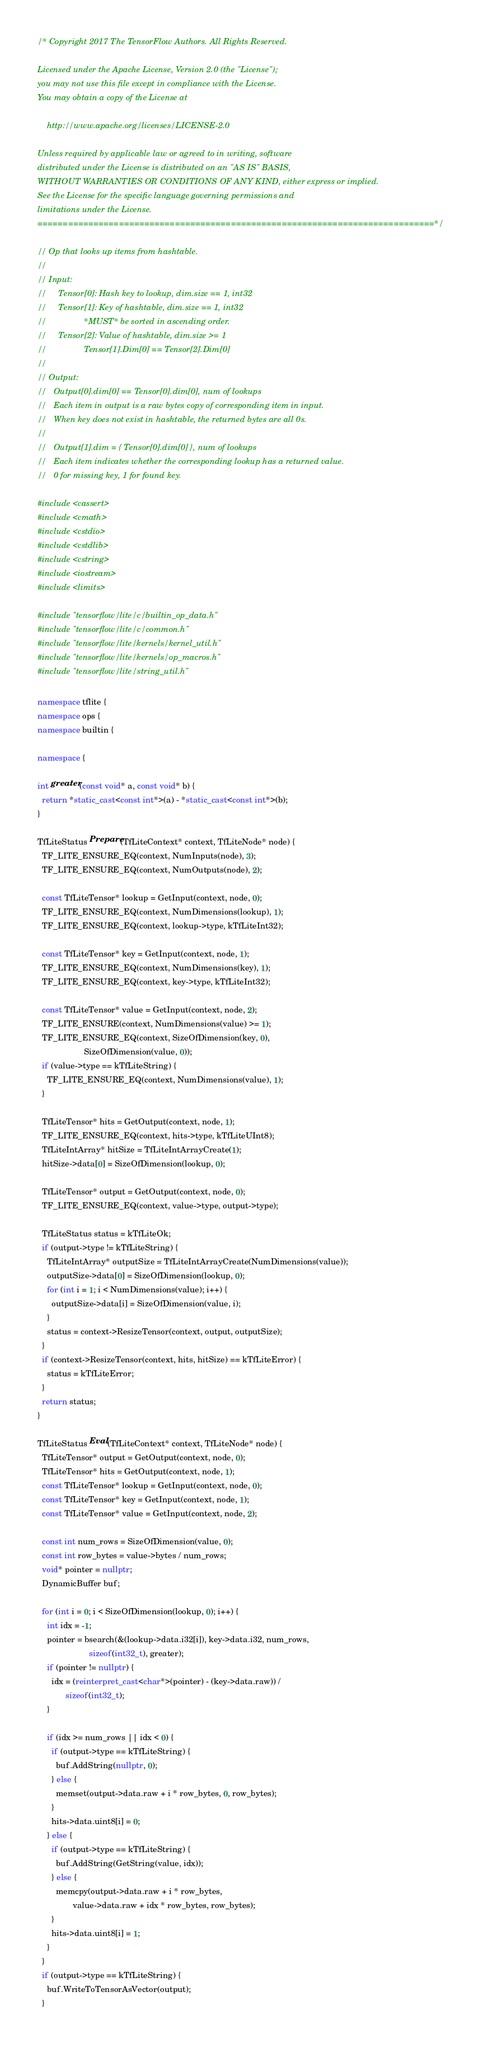<code> <loc_0><loc_0><loc_500><loc_500><_C++_>/* Copyright 2017 The TensorFlow Authors. All Rights Reserved.

Licensed under the Apache License, Version 2.0 (the "License");
you may not use this file except in compliance with the License.
You may obtain a copy of the License at

    http://www.apache.org/licenses/LICENSE-2.0

Unless required by applicable law or agreed to in writing, software
distributed under the License is distributed on an "AS IS" BASIS,
WITHOUT WARRANTIES OR CONDITIONS OF ANY KIND, either express or implied.
See the License for the specific language governing permissions and
limitations under the License.
==============================================================================*/

// Op that looks up items from hashtable.
//
// Input:
//     Tensor[0]: Hash key to lookup, dim.size == 1, int32
//     Tensor[1]: Key of hashtable, dim.size == 1, int32
//                *MUST* be sorted in ascending order.
//     Tensor[2]: Value of hashtable, dim.size >= 1
//                Tensor[1].Dim[0] == Tensor[2].Dim[0]
//
// Output:
//   Output[0].dim[0] == Tensor[0].dim[0], num of lookups
//   Each item in output is a raw bytes copy of corresponding item in input.
//   When key does not exist in hashtable, the returned bytes are all 0s.
//
//   Output[1].dim = { Tensor[0].dim[0] }, num of lookups
//   Each item indicates whether the corresponding lookup has a returned value.
//   0 for missing key, 1 for found key.

#include <cassert>
#include <cmath>
#include <cstdio>
#include <cstdlib>
#include <cstring>
#include <iostream>
#include <limits>

#include "tensorflow/lite/c/builtin_op_data.h"
#include "tensorflow/lite/c/common.h"
#include "tensorflow/lite/kernels/kernel_util.h"
#include "tensorflow/lite/kernels/op_macros.h"
#include "tensorflow/lite/string_util.h"

namespace tflite {
namespace ops {
namespace builtin {

namespace {

int greater(const void* a, const void* b) {
  return *static_cast<const int*>(a) - *static_cast<const int*>(b);
}

TfLiteStatus Prepare(TfLiteContext* context, TfLiteNode* node) {
  TF_LITE_ENSURE_EQ(context, NumInputs(node), 3);
  TF_LITE_ENSURE_EQ(context, NumOutputs(node), 2);

  const TfLiteTensor* lookup = GetInput(context, node, 0);
  TF_LITE_ENSURE_EQ(context, NumDimensions(lookup), 1);
  TF_LITE_ENSURE_EQ(context, lookup->type, kTfLiteInt32);

  const TfLiteTensor* key = GetInput(context, node, 1);
  TF_LITE_ENSURE_EQ(context, NumDimensions(key), 1);
  TF_LITE_ENSURE_EQ(context, key->type, kTfLiteInt32);

  const TfLiteTensor* value = GetInput(context, node, 2);
  TF_LITE_ENSURE(context, NumDimensions(value) >= 1);
  TF_LITE_ENSURE_EQ(context, SizeOfDimension(key, 0),
                    SizeOfDimension(value, 0));
  if (value->type == kTfLiteString) {
    TF_LITE_ENSURE_EQ(context, NumDimensions(value), 1);
  }

  TfLiteTensor* hits = GetOutput(context, node, 1);
  TF_LITE_ENSURE_EQ(context, hits->type, kTfLiteUInt8);
  TfLiteIntArray* hitSize = TfLiteIntArrayCreate(1);
  hitSize->data[0] = SizeOfDimension(lookup, 0);

  TfLiteTensor* output = GetOutput(context, node, 0);
  TF_LITE_ENSURE_EQ(context, value->type, output->type);

  TfLiteStatus status = kTfLiteOk;
  if (output->type != kTfLiteString) {
    TfLiteIntArray* outputSize = TfLiteIntArrayCreate(NumDimensions(value));
    outputSize->data[0] = SizeOfDimension(lookup, 0);
    for (int i = 1; i < NumDimensions(value); i++) {
      outputSize->data[i] = SizeOfDimension(value, i);
    }
    status = context->ResizeTensor(context, output, outputSize);
  }
  if (context->ResizeTensor(context, hits, hitSize) == kTfLiteError) {
    status = kTfLiteError;
  }
  return status;
}

TfLiteStatus Eval(TfLiteContext* context, TfLiteNode* node) {
  TfLiteTensor* output = GetOutput(context, node, 0);
  TfLiteTensor* hits = GetOutput(context, node, 1);
  const TfLiteTensor* lookup = GetInput(context, node, 0);
  const TfLiteTensor* key = GetInput(context, node, 1);
  const TfLiteTensor* value = GetInput(context, node, 2);

  const int num_rows = SizeOfDimension(value, 0);
  const int row_bytes = value->bytes / num_rows;
  void* pointer = nullptr;
  DynamicBuffer buf;

  for (int i = 0; i < SizeOfDimension(lookup, 0); i++) {
    int idx = -1;
    pointer = bsearch(&(lookup->data.i32[i]), key->data.i32, num_rows,
                      sizeof(int32_t), greater);
    if (pointer != nullptr) {
      idx = (reinterpret_cast<char*>(pointer) - (key->data.raw)) /
            sizeof(int32_t);
    }

    if (idx >= num_rows || idx < 0) {
      if (output->type == kTfLiteString) {
        buf.AddString(nullptr, 0);
      } else {
        memset(output->data.raw + i * row_bytes, 0, row_bytes);
      }
      hits->data.uint8[i] = 0;
    } else {
      if (output->type == kTfLiteString) {
        buf.AddString(GetString(value, idx));
      } else {
        memcpy(output->data.raw + i * row_bytes,
               value->data.raw + idx * row_bytes, row_bytes);
      }
      hits->data.uint8[i] = 1;
    }
  }
  if (output->type == kTfLiteString) {
    buf.WriteToTensorAsVector(output);
  }
</code> 